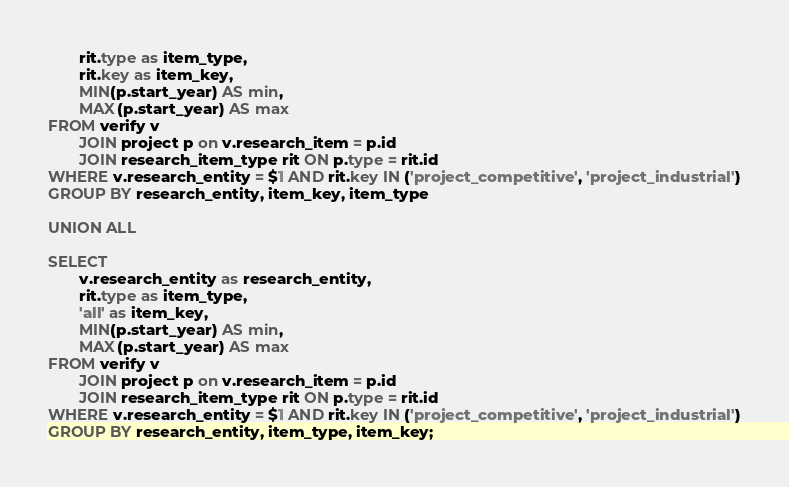Convert code to text. <code><loc_0><loc_0><loc_500><loc_500><_SQL_>       rit.type as item_type,
       rit.key as item_key,
       MIN(p.start_year) AS min,
       MAX(p.start_year) AS max
FROM verify v
       JOIN project p on v.research_item = p.id
       JOIN research_item_type rit ON p.type = rit.id
WHERE v.research_entity = $1 AND rit.key IN ('project_competitive', 'project_industrial')
GROUP BY research_entity, item_key, item_type

UNION ALL

SELECT
       v.research_entity as research_entity,
       rit.type as item_type,
       'all' as item_key,
       MIN(p.start_year) AS min,
       MAX(p.start_year) AS max
FROM verify v
       JOIN project p on v.research_item = p.id
       JOIN research_item_type rit ON p.type = rit.id
WHERE v.research_entity = $1 AND rit.key IN ('project_competitive', 'project_industrial')
GROUP BY research_entity, item_type, item_key;</code> 